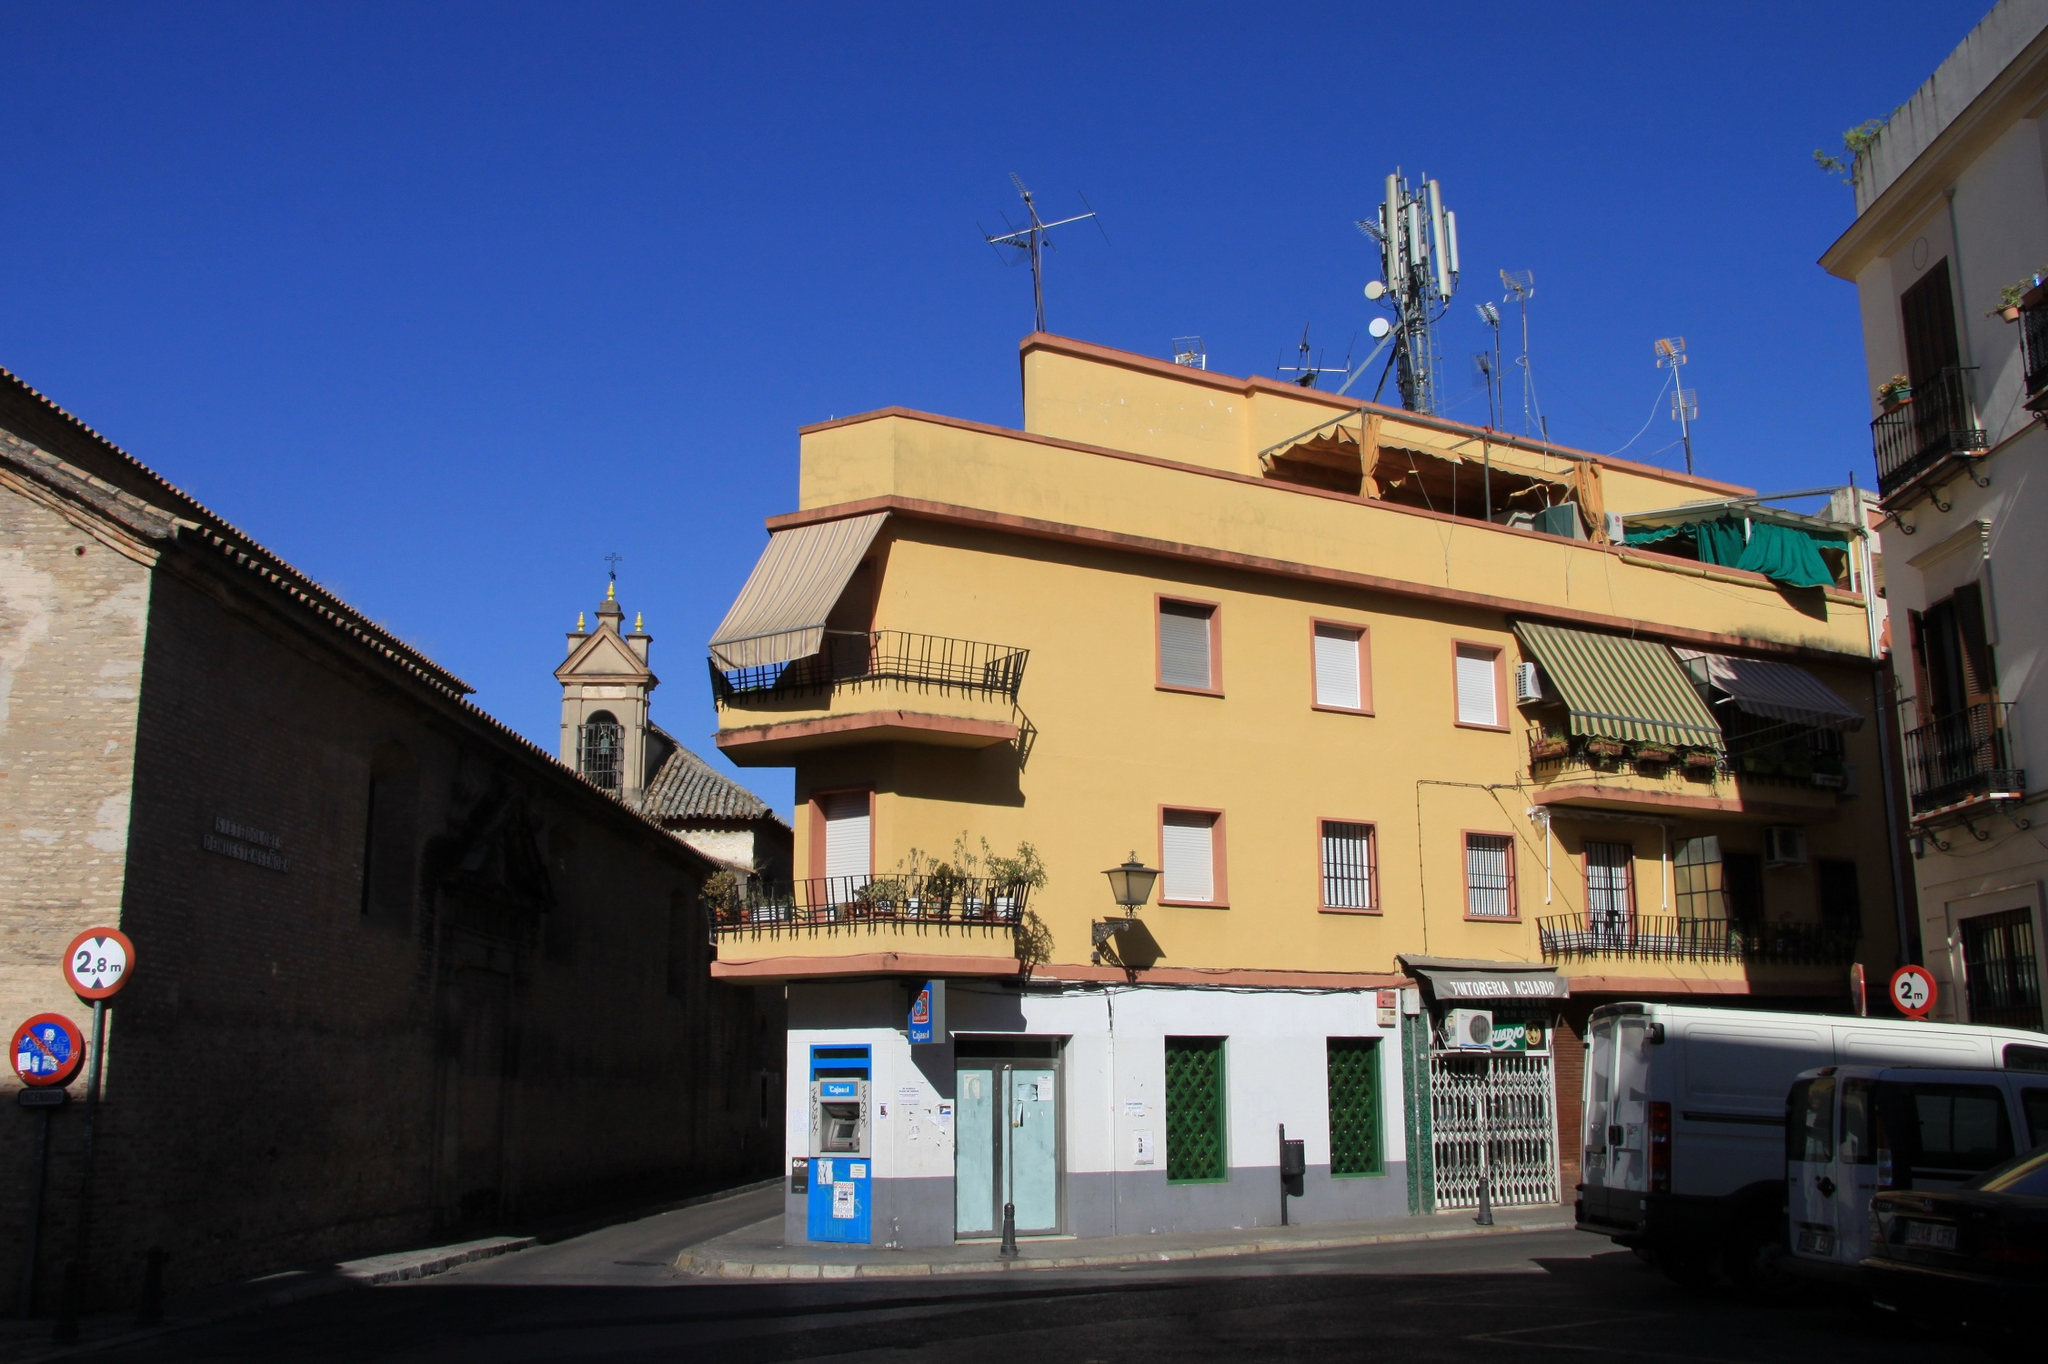Imagine if the yellow building could talk. What stories would it tell? If the yellow building could talk, it would share stories etched in its vibrant walls. It would speak of the children who grew up within its sturdy structure, their laughter echoing through the halls. It would recount tales of the changing seasons, describing how the plants on the balconies bloom in spring, creating a colorful facade, while in winter, the chilly winds whistle through the narrow streets. The building might remember the day when the church bells tolled non-stop to celebrate a historic event and how the community gathered near its doorsteps. It would reminisce about the renovations that gave it a fresh yellow coat, a transformation that brought renewed vigor and energy. Each window, door, and balcony would have its own anecdotes to share, from the romantic moments observed under the starry sky to the everyday rituals of residents unwinding after a long day's work. This building holds within its walls a tapestry of life's simple yet profound moments, a witness to the passage of time in this bustling city corner. 